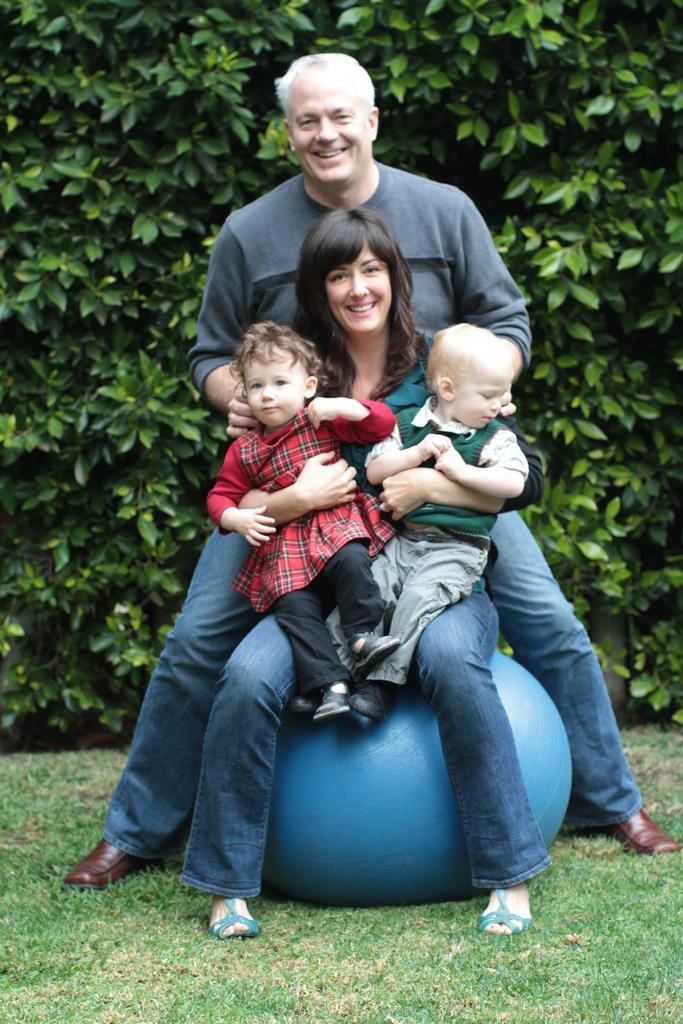Please provide a concise description of this image. In this image there is a family sitting on the bean bag, behind them there are so many trees. 